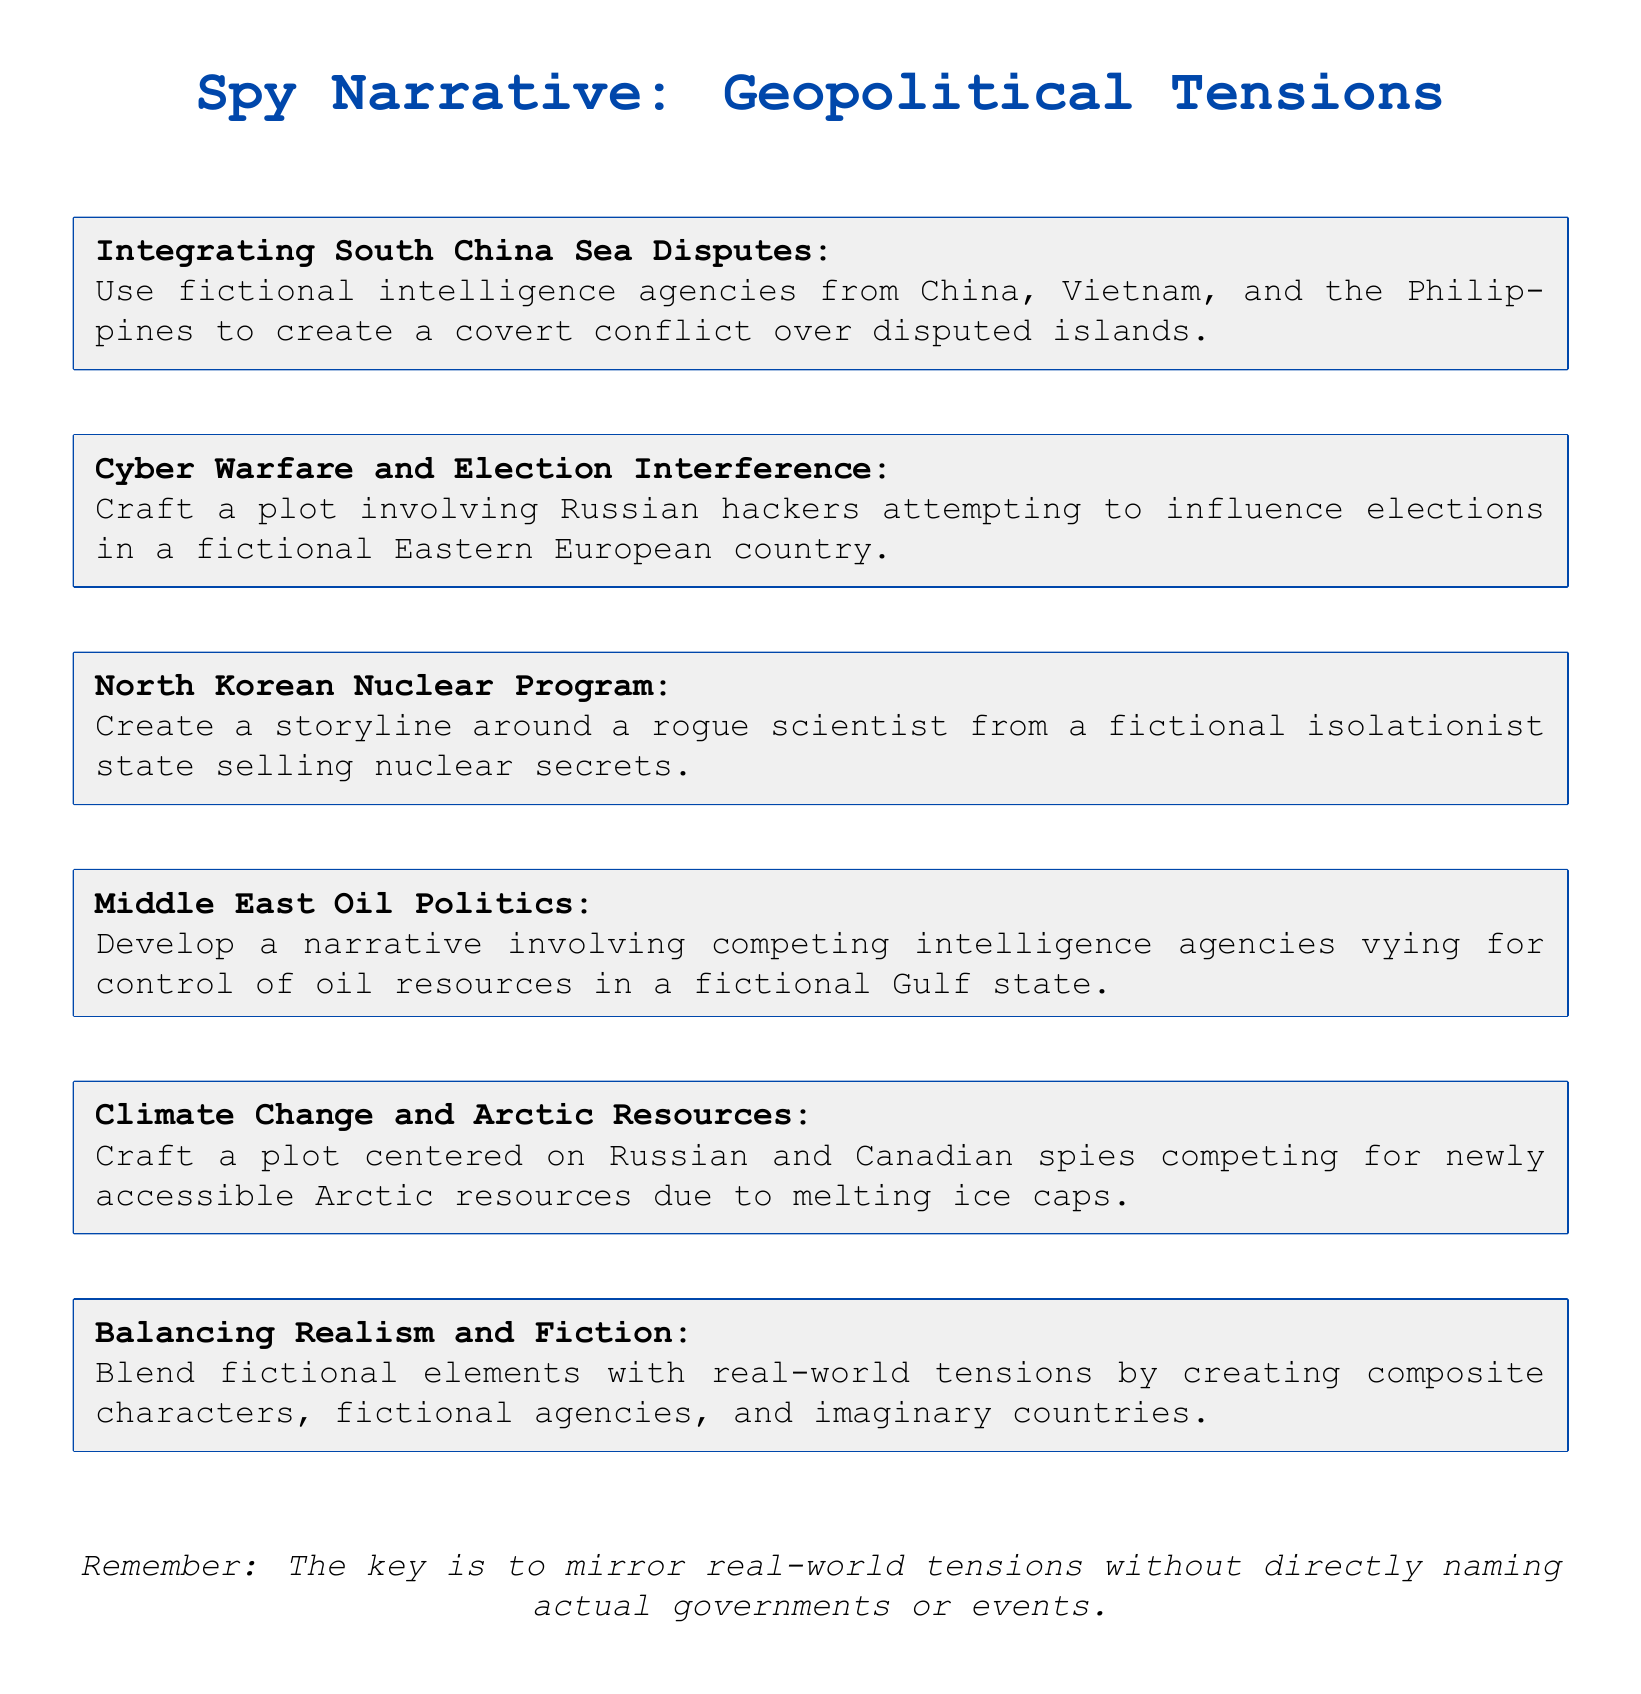What is the first plot idea mentioned? The first plot idea is titled "Integrating South China Sea Disputes," which involves fictional intelligence agencies from China, Vietnam, and the Philippines.
Answer: Integrating South China Sea Disputes How many plot ideas focus on oil politics? The document includes one plot idea that involves competing intelligence agencies vying for control of oil resources in a fictional Gulf state, which pertains to oil politics.
Answer: One What fictional aspect is emphasized in blending realism and fiction? The emphasis is on creating composite characters, fictional agencies, and imaginary countries that embody aspects of real-world entities.
Answer: Composite characters Which geopolitical issue is linked to climate change in the document? The plot idea relates to Russian and Canadian spies competing for newly accessible Arctic resources due to melting ice caps.
Answer: Arctic resources What kind of plot does the idea regarding cyber warfare suggest? The plot involves Russian hackers attempting to influence elections in a fictional Eastern European country.
Answer: Influence elections What general strategy is suggested for incorporating real-world tensions? The document advises mirroring real-world tensions without directly naming actual governments or events.
Answer: Mirror real-world tensions 